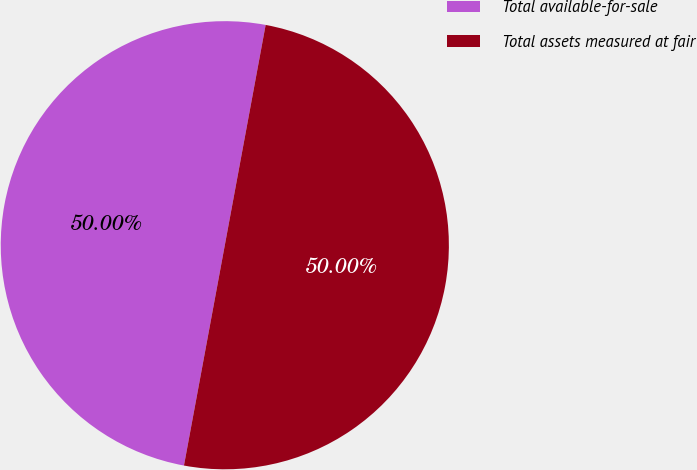Convert chart. <chart><loc_0><loc_0><loc_500><loc_500><pie_chart><fcel>Total available-for-sale<fcel>Total assets measured at fair<nl><fcel>50.0%<fcel>50.0%<nl></chart> 